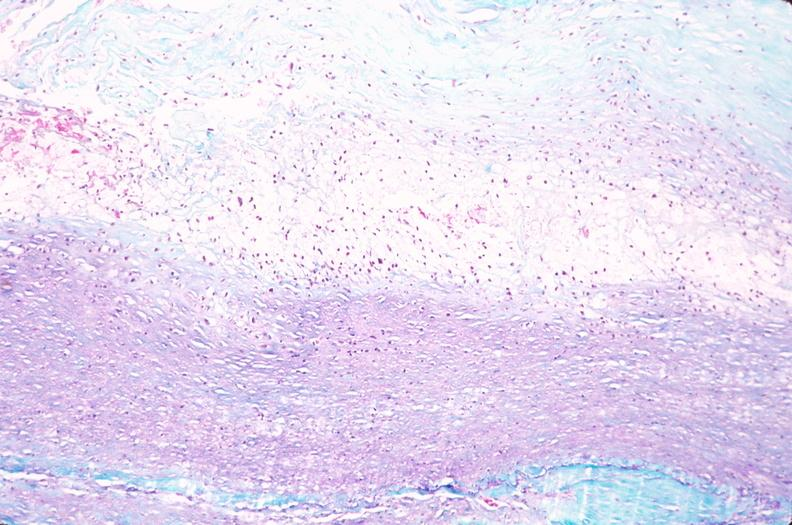s coronary artery present?
Answer the question using a single word or phrase. No 